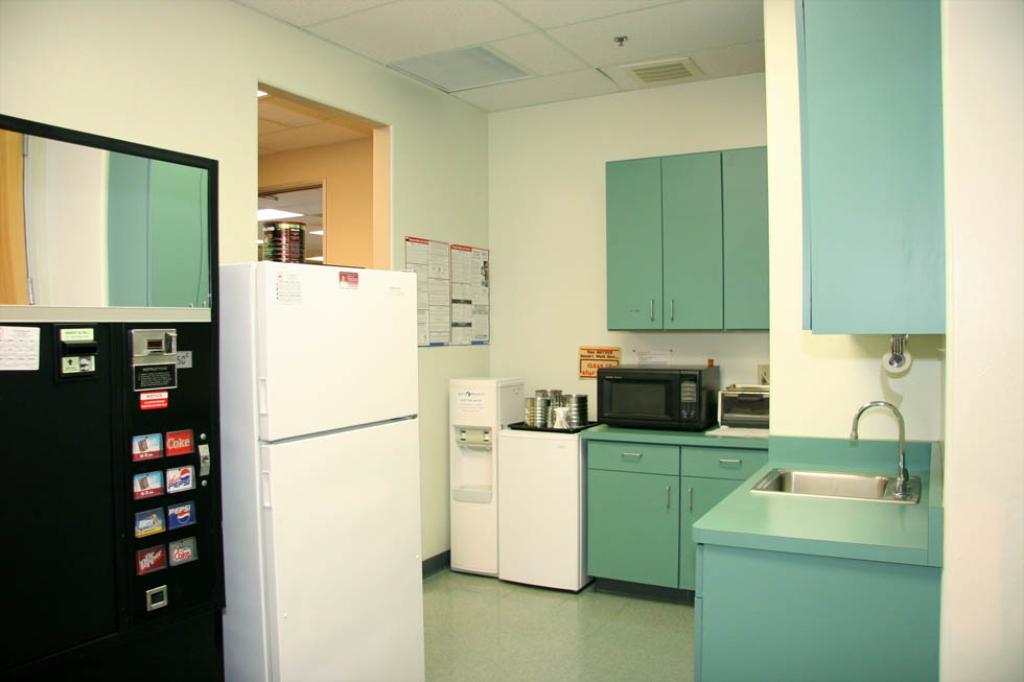Do they have coke in the machine?
Your answer should be very brief. Yes. What is the bottom left soda on the machine?
Give a very brief answer. Dr pepper. 